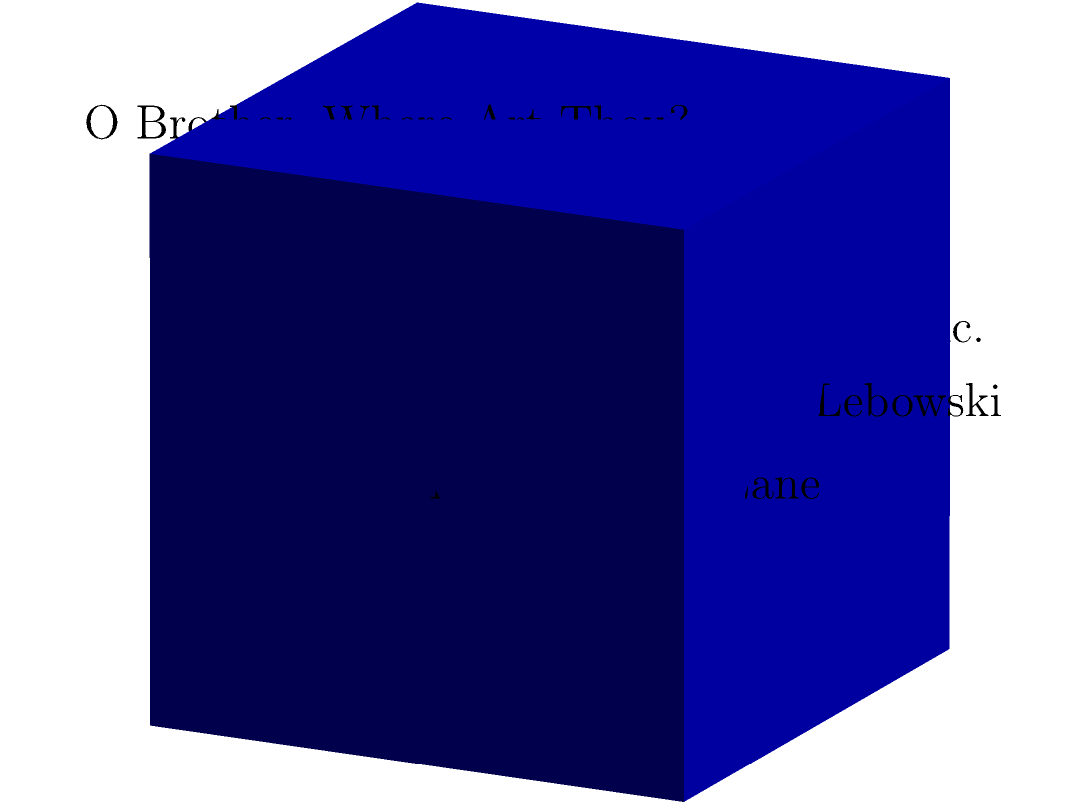A dedicated John Goodman fan wants to create a unique cube-shaped display for his favorite actor's most iconic roles. Each face of the cube will feature a scene from one of Goodman's famous movies: "The Big Lebowski," "Barton Fink," "10 Cloverfield Lane," "Monsters, Inc.," "O Brother, Where Art Thou?," and "Argo." If the edge length of the cube is 24 inches, what is the total surface area that will be decorated with John Goodman's movie scenes? To solve this problem, we need to follow these steps:

1. Recall the formula for the surface area of a cube:
   Surface Area = $6s^2$, where $s$ is the length of one edge.

2. We are given that the edge length is 24 inches.

3. Let's substitute this value into our formula:
   Surface Area = $6 \times (24\text{ in})^2$

4. Simplify the calculation:
   Surface Area = $6 \times 576\text{ in}^2$
                = $3,456\text{ in}^2$

5. Therefore, the total surface area that will be decorated with scenes from John Goodman's movies is 3,456 square inches.

This surface area includes all six faces of the cube, each featuring a different iconic John Goodman movie:
- Top face: "The Big Lebowski"
- Bottom face: "Barton Fink"
- Front face: "10 Cloverfield Lane"
- Back face: "Monsters, Inc."
- Right face: "O Brother, Where Art Thou?"
- Left face: "Argo"
Answer: $3,456\text{ in}^2$ 